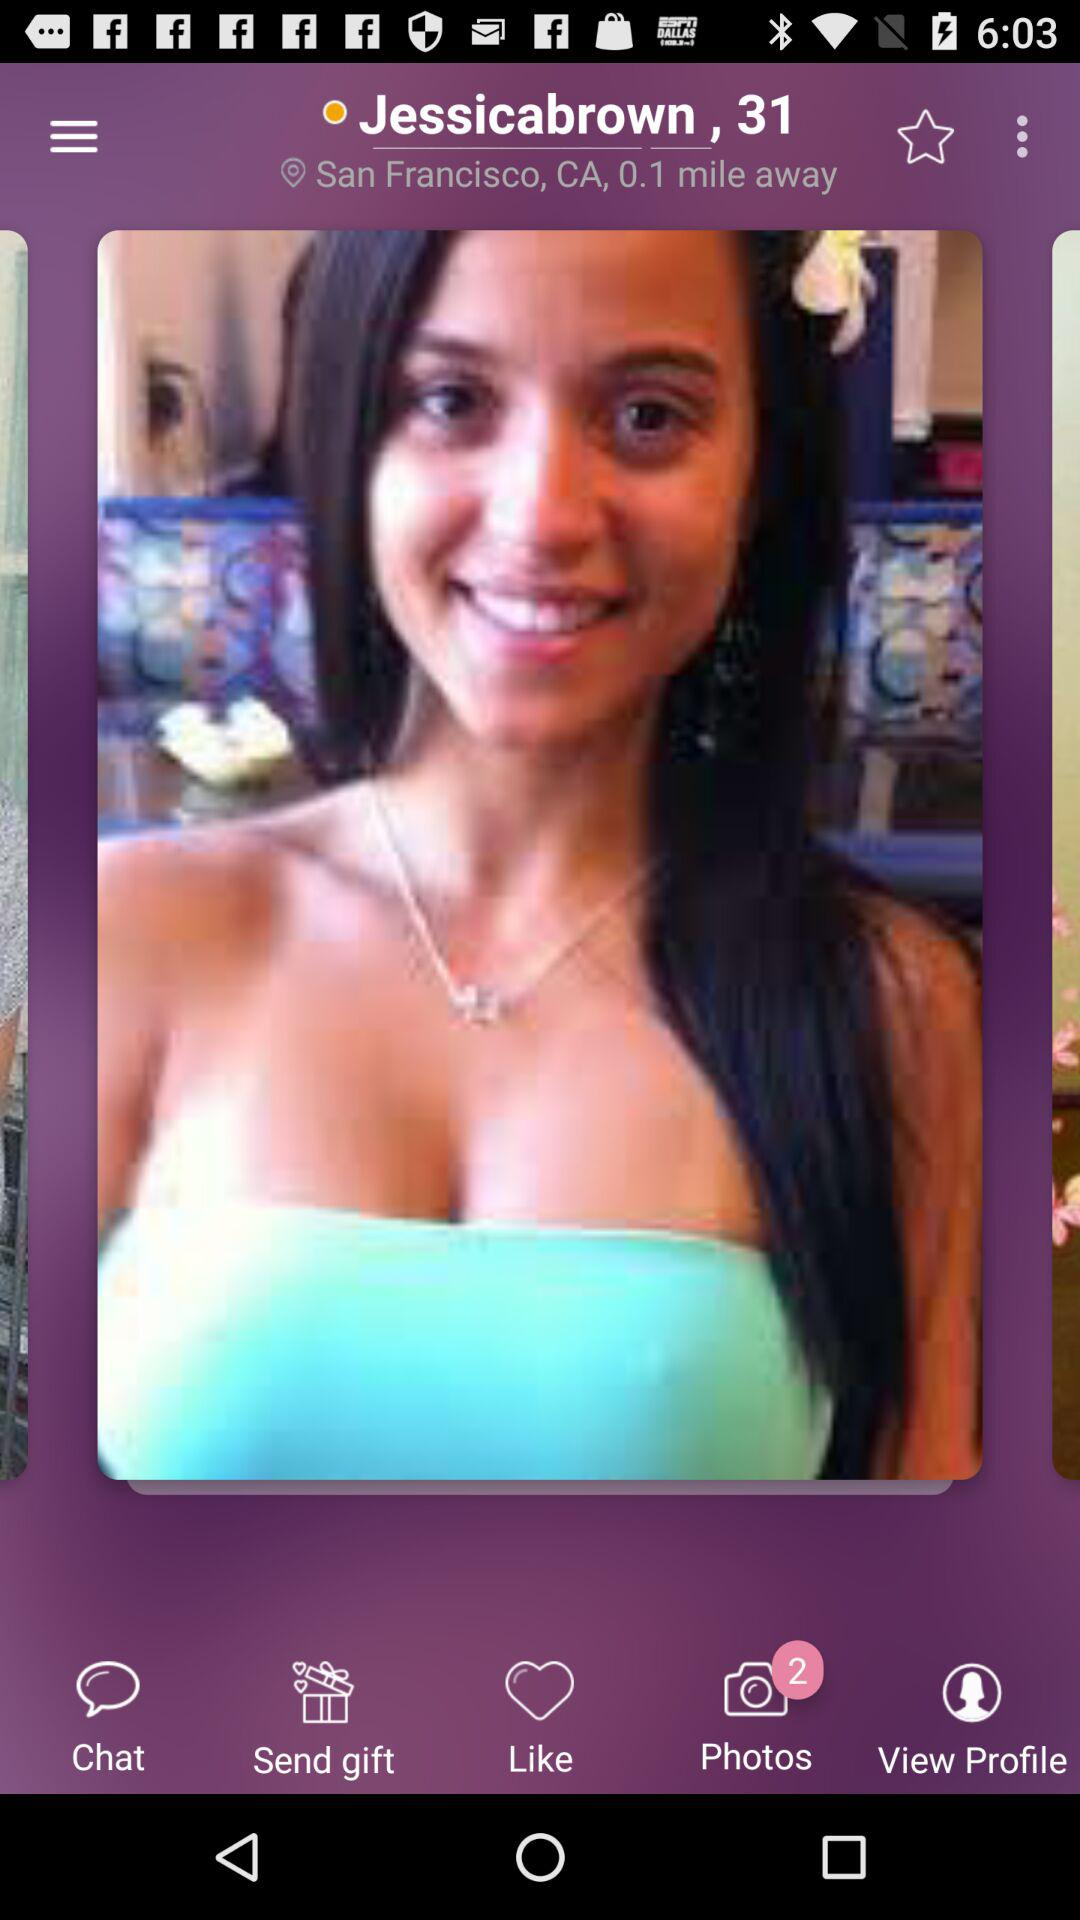What is the age of the user? The age of the user is 31 years. 